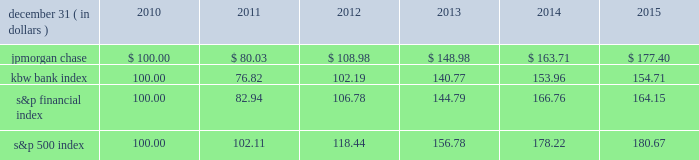Jpmorgan chase & co./2015 annual report 67 five-year stock performance the table and graph compare the five-year cumulative total return for jpmorgan chase & co .
( 201cjpmorgan chase 201d or the 201cfirm 201d ) common stock with the cumulative return of the s&p 500 index , the kbw bank index and the s&p financial index .
The s&p 500 index is a commonly referenced united states of america ( 201cu.s . 201d ) equity benchmark consisting of leading companies from different economic sectors .
The kbw bank index seeks to reflect the performance of banks and thrifts that are publicly traded in the u.s .
And is composed of 24 leading national money center and regional banks and thrifts .
The s&p financial index is an index of 87 financial companies , all of which are components of the s&p 500 .
The firm is a component of all three industry indices .
The table and graph assume simultaneous investments of $ 100 on december 31 , 2010 , in jpmorgan chase common stock and in each of the above indices .
The comparison assumes that all dividends are reinvested .
December 31 , ( in dollars ) 2010 2011 2012 2013 2014 2015 .
December 31 , ( in dollars ) .
What was the 5 year return of the s&p financial index? 
Computations: ((164.15 - 100) / 100)
Answer: 0.6415. 